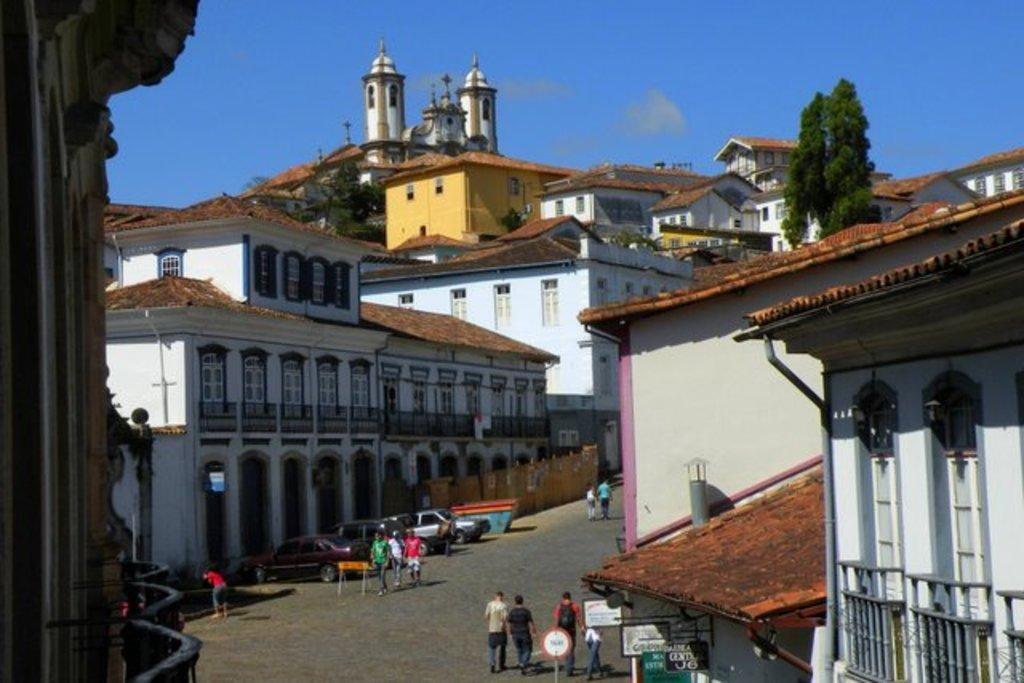How many people are in the image? There are people in the image, but the exact number is not specified. What can be seen on the boards in the image? There is text on boards in the image. What type of structures are visible in the image? There are buildings in the image. What type of vegetation is present in the image? There are trees in the image. What other objects can be seen in the image besides people, boards, buildings, and trees? There are other objects in the image, but their specific nature is not mentioned. What is visible in the sky in the image? The sky is visible in the image with clouds. What type of arithmetic problem is being solved on the hospital bed in the image? There is no hospital bed or arithmetic problem present in the image. 